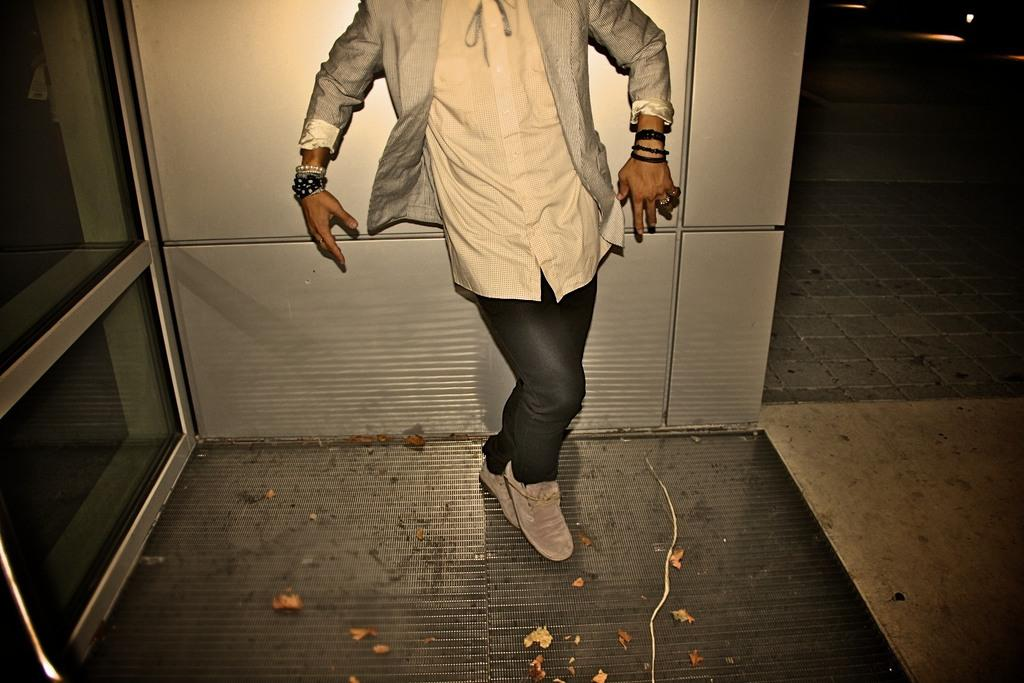What is the main subject of the image? There is a person standing in the image. What can be seen on the left side of the image? There is a glass wall on the left side of the image. Can you describe the lighting in the image? There is a light at the back of the image. What type of trousers is the army wearing in the image? There is no army or trousers present in the image; it features a person standing near a glass wall with a light at the back. What is the head doing in the image? The image does not show a head or any specific action being performed by the person's head. 